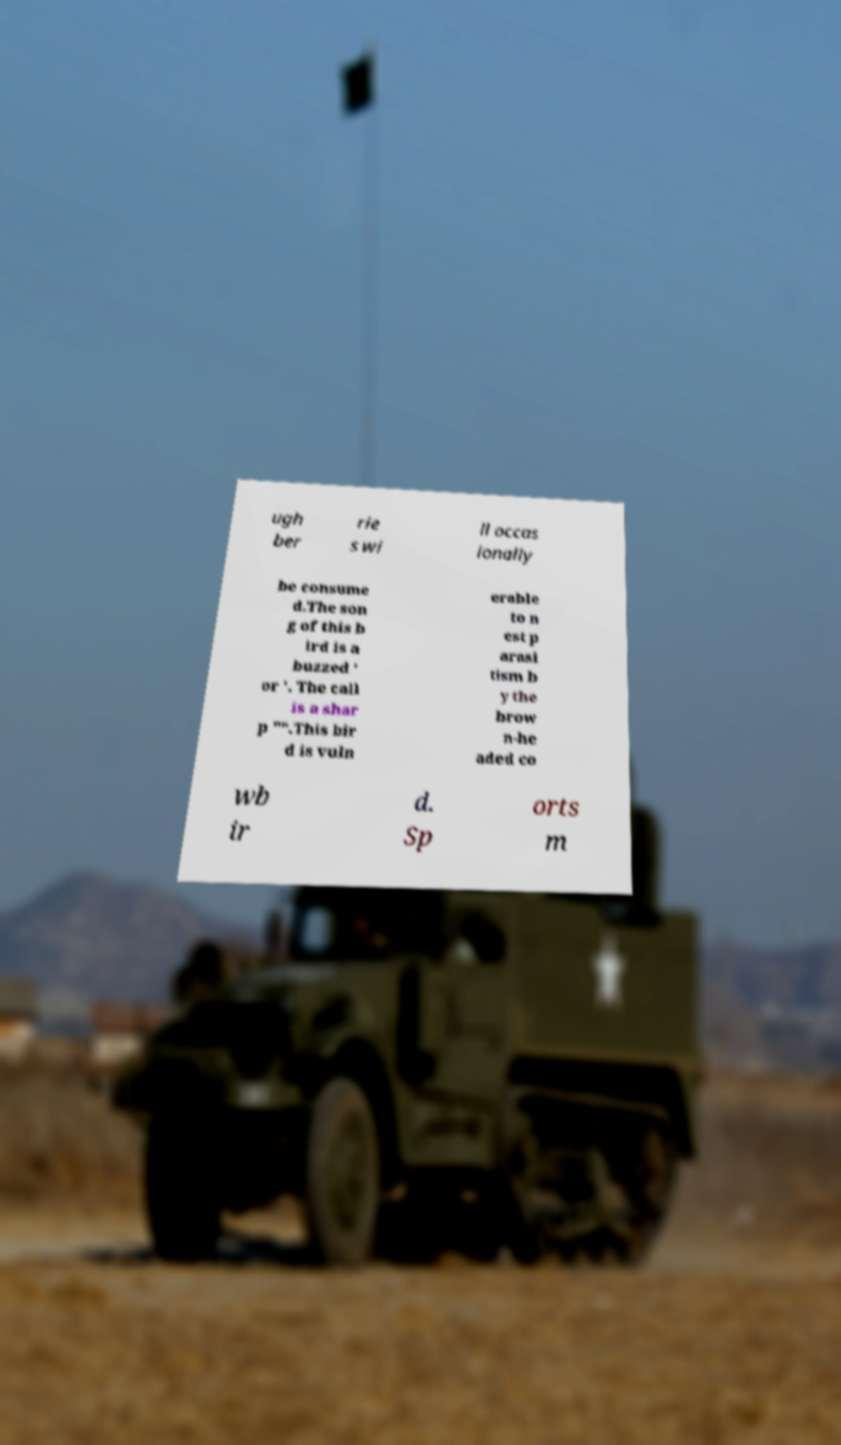Could you extract and type out the text from this image? ugh ber rie s wi ll occas ionally be consume d.The son g of this b ird is a buzzed ' or '. The call is a shar p "".This bir d is vuln erable to n est p arasi tism b y the brow n-he aded co wb ir d. Sp orts m 